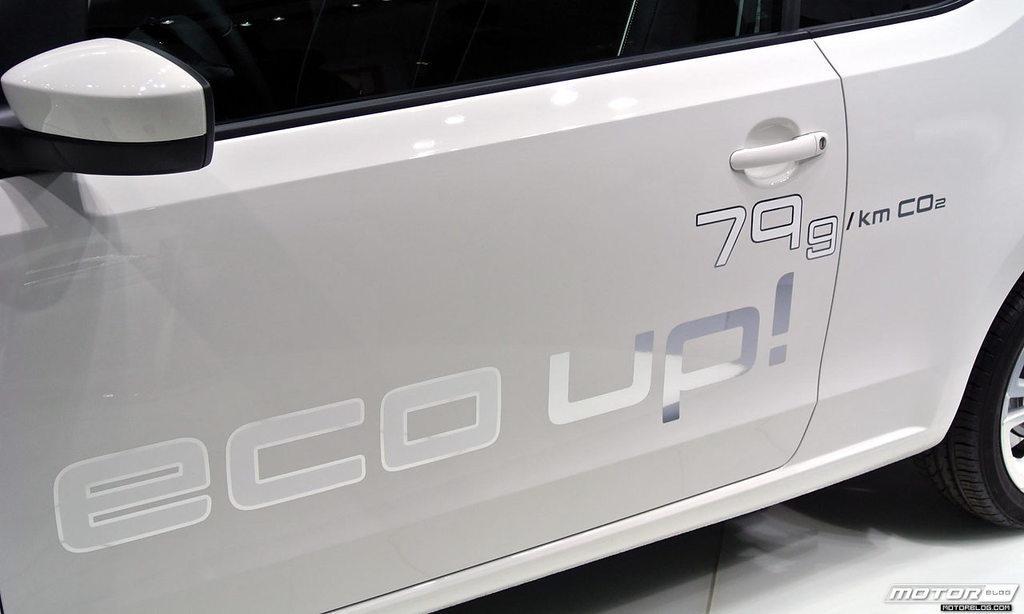Please provide a concise description of this image. In this image I can see a mirror and a door of a white colour vehicle. Here I can see something is written and I can also see a wheel of this vehicle. 